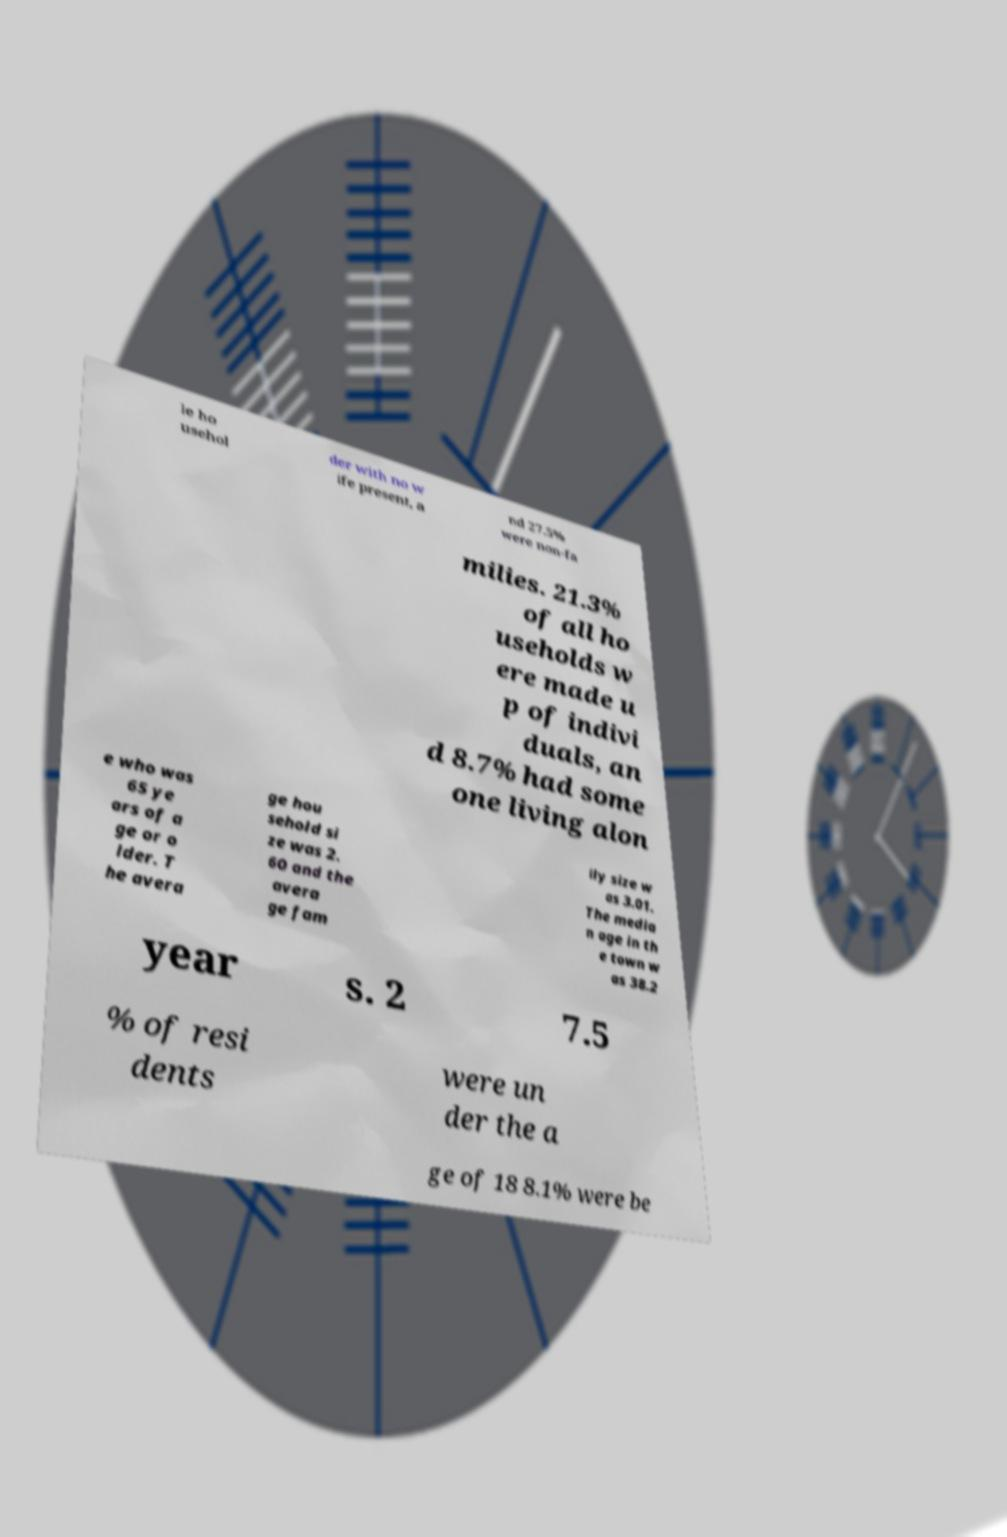Could you extract and type out the text from this image? le ho usehol der with no w ife present, a nd 27.5% were non-fa milies. 21.3% of all ho useholds w ere made u p of indivi duals, an d 8.7% had some one living alon e who was 65 ye ars of a ge or o lder. T he avera ge hou sehold si ze was 2. 60 and the avera ge fam ily size w as 3.01. The media n age in th e town w as 38.2 year s. 2 7.5 % of resi dents were un der the a ge of 18 8.1% were be 